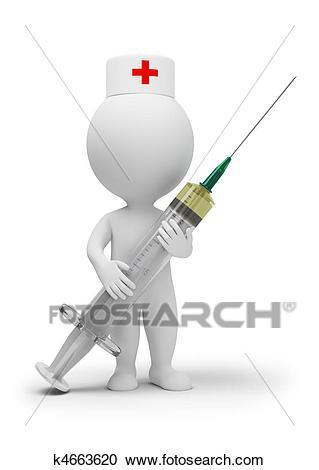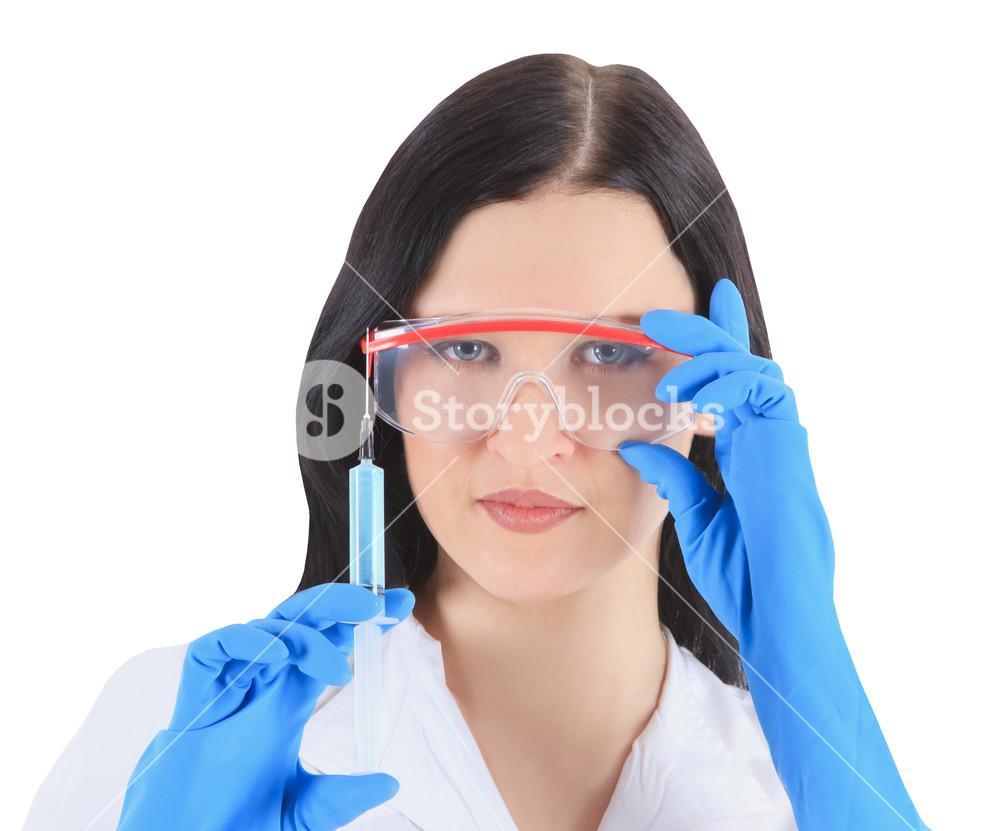The first image is the image on the left, the second image is the image on the right. For the images shown, is this caption "There are two women holding needles." true? Answer yes or no. No. The first image is the image on the left, the second image is the image on the right. Assess this claim about the two images: "Two women are holding syringes.". Correct or not? Answer yes or no. No. 